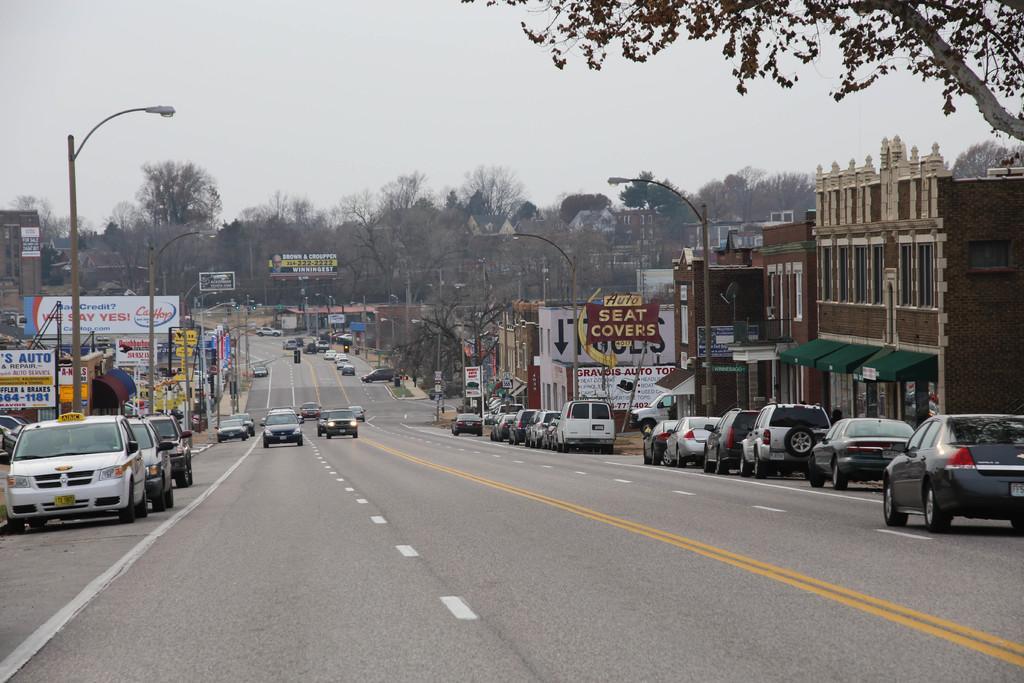How would you summarize this image in a sentence or two? In the image on the road there are many cars. There are many buildings with wall, windows and roofs. And also there are poles with street lights, name boards, sign boards and banners. There are many trees in the background. At the top of the image there is a sky. 